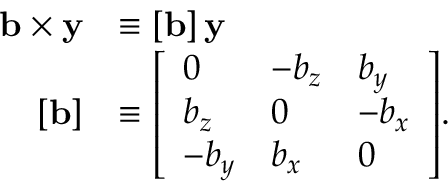<formula> <loc_0><loc_0><loc_500><loc_500>{ \begin{array} { r l } { b \times y } & { \equiv \left [ b \right ] y } \\ { \left [ b \right ] } & { \equiv \left [ \begin{array} { l l l } { 0 } & { - b _ { z } } & { b _ { y } } \\ { b _ { z } } & { 0 } & { - b _ { x } } \\ { - b _ { y } } & { b _ { x } } & { 0 } \end{array} \right ] . } \end{array} }</formula> 